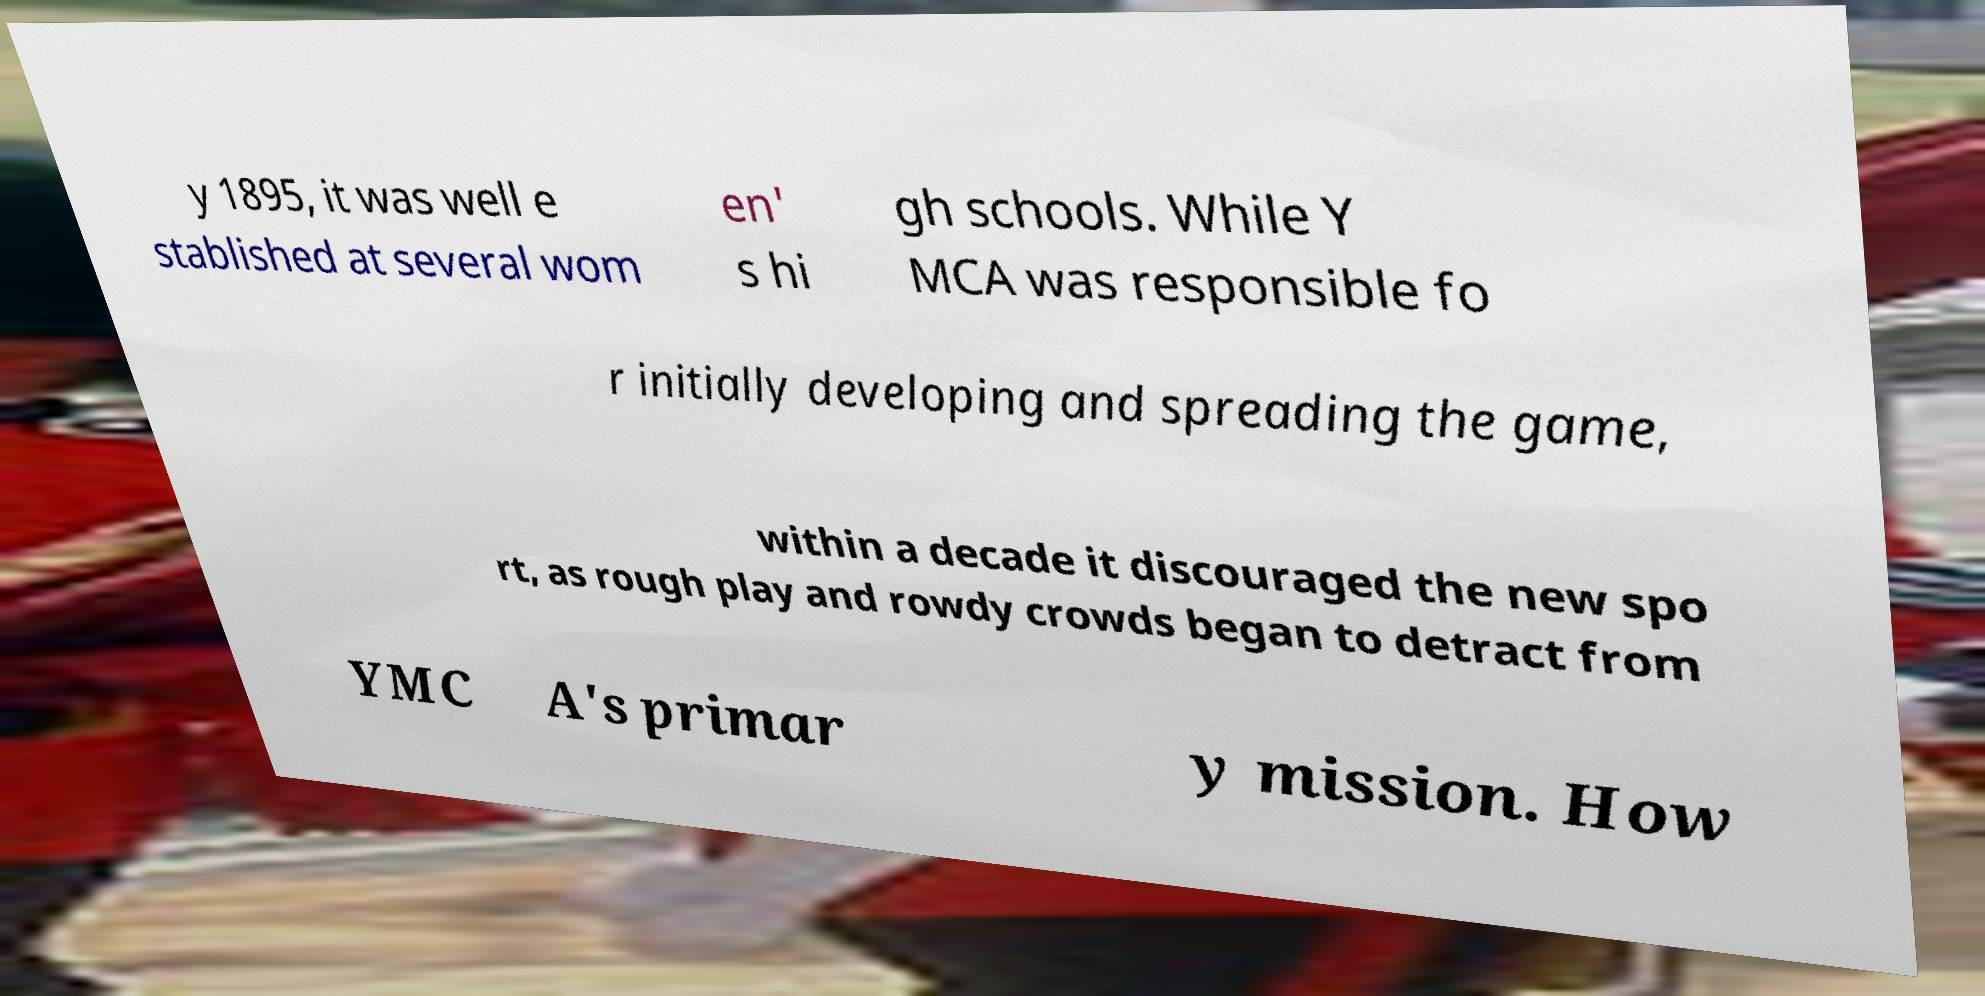Please identify and transcribe the text found in this image. y 1895, it was well e stablished at several wom en' s hi gh schools. While Y MCA was responsible fo r initially developing and spreading the game, within a decade it discouraged the new spo rt, as rough play and rowdy crowds began to detract from YMC A's primar y mission. How 